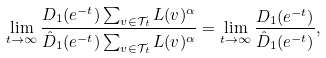Convert formula to latex. <formula><loc_0><loc_0><loc_500><loc_500>\lim _ { t \to \infty } \frac { D _ { 1 } ( e ^ { - t } ) \sum _ { v \in \mathcal { T } _ { t } } L ( v ) ^ { \alpha } } { \hat { D } _ { 1 } ( e ^ { - t } ) \sum _ { v \in \mathcal { T } _ { t } } L ( v ) ^ { \alpha } } = \lim _ { t \to \infty } \frac { D _ { 1 } ( e ^ { - t } ) } { \hat { D } _ { 1 } ( e ^ { - t } ) } ,</formula> 